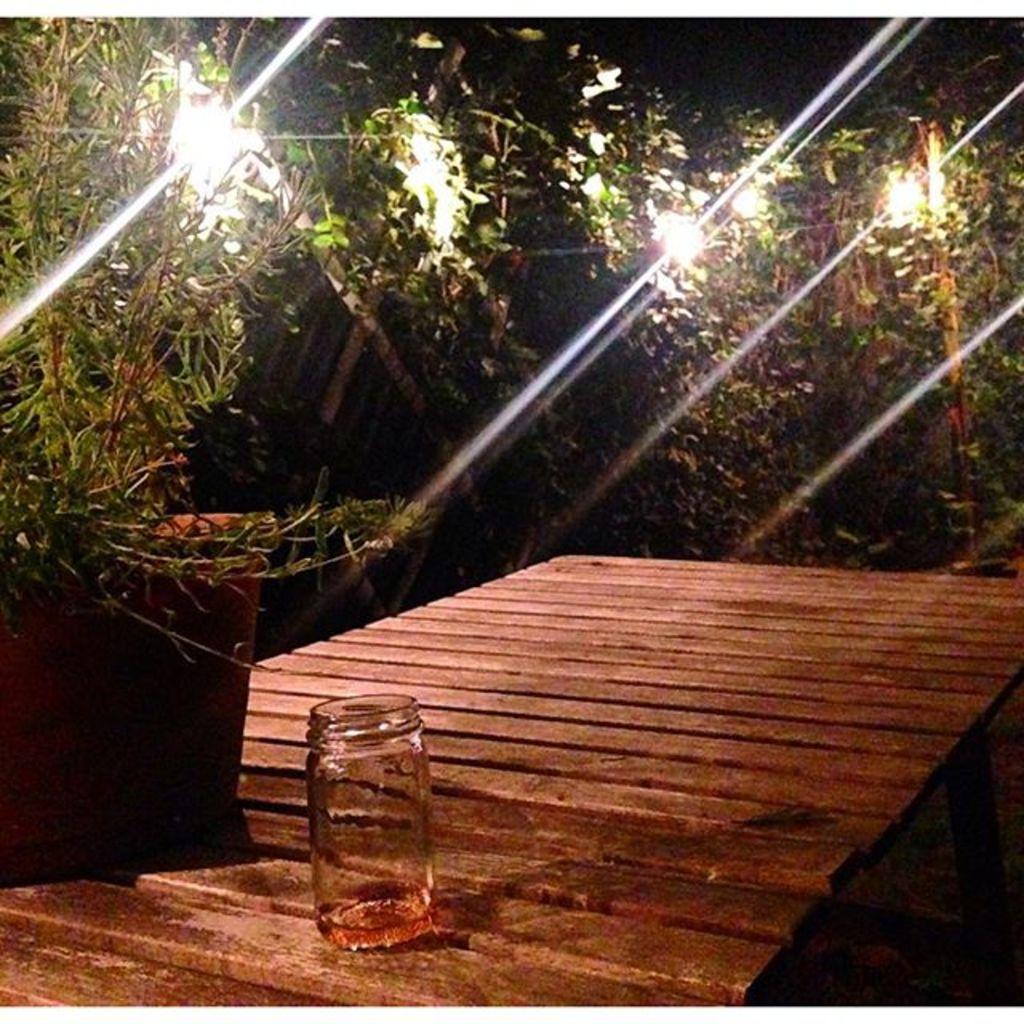Describe this image in one or two sentences. In this picture we can see trees and in between trees we have lights and in front we have flower pot with plant, table and on table there is glass jar. 